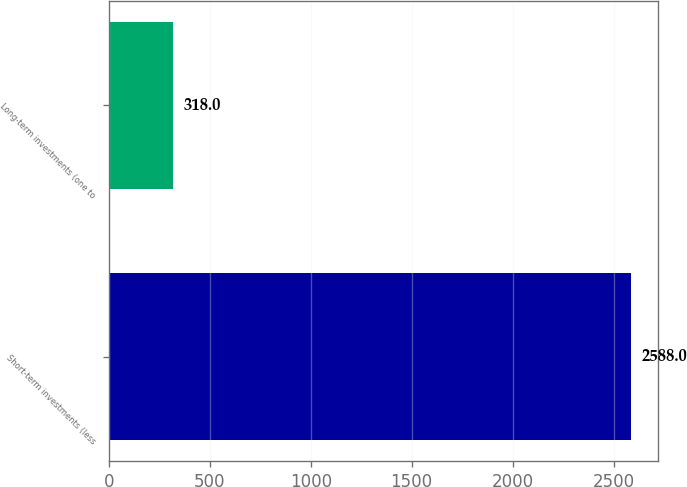<chart> <loc_0><loc_0><loc_500><loc_500><bar_chart><fcel>Short-term investments (less<fcel>Long-term investments (one to<nl><fcel>2588<fcel>318<nl></chart> 